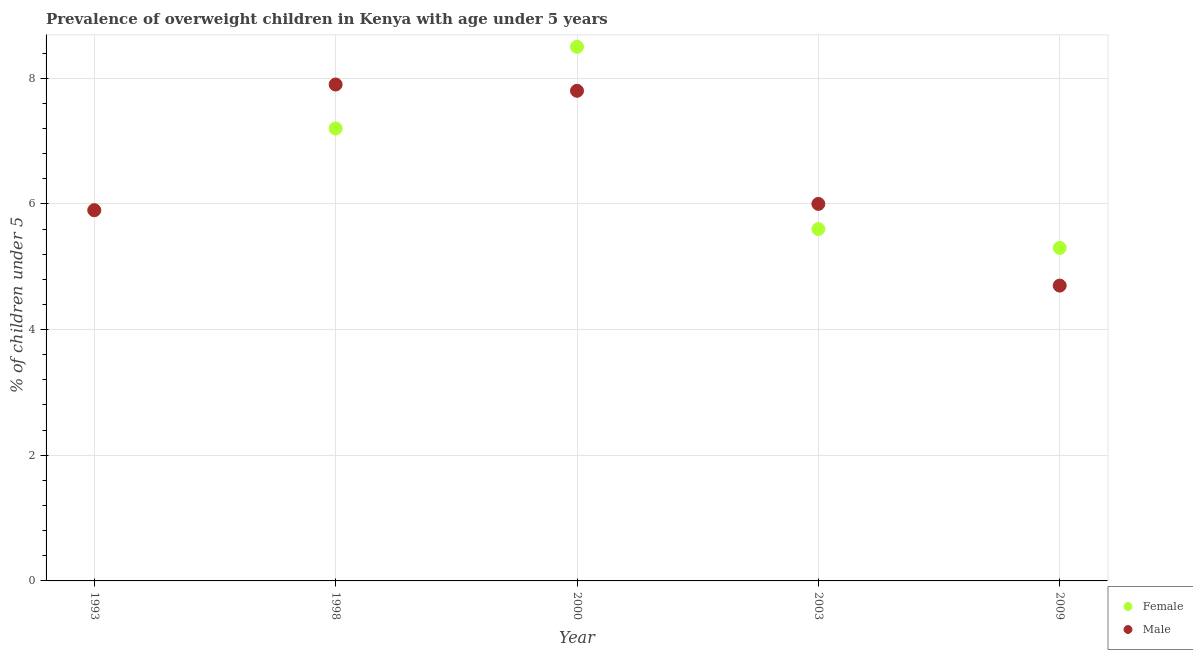What is the percentage of obese male children in 2003?
Your answer should be very brief. 6. Across all years, what is the maximum percentage of obese male children?
Provide a succinct answer. 7.9. Across all years, what is the minimum percentage of obese female children?
Your answer should be compact. 5.3. In which year was the percentage of obese female children minimum?
Offer a very short reply. 2009. What is the total percentage of obese male children in the graph?
Offer a very short reply. 32.3. What is the difference between the percentage of obese female children in 2003 and that in 2009?
Make the answer very short. 0.3. What is the difference between the percentage of obese male children in 1993 and the percentage of obese female children in 2009?
Keep it short and to the point. 0.6. What is the average percentage of obese male children per year?
Your answer should be compact. 6.46. In the year 2009, what is the difference between the percentage of obese male children and percentage of obese female children?
Provide a short and direct response. -0.6. In how many years, is the percentage of obese male children greater than 0.4 %?
Make the answer very short. 5. What is the ratio of the percentage of obese female children in 1993 to that in 1998?
Your response must be concise. 0.82. Is the difference between the percentage of obese female children in 2000 and 2003 greater than the difference between the percentage of obese male children in 2000 and 2003?
Provide a short and direct response. Yes. What is the difference between the highest and the second highest percentage of obese male children?
Offer a terse response. 0.1. What is the difference between the highest and the lowest percentage of obese male children?
Provide a succinct answer. 3.2. Is the percentage of obese male children strictly greater than the percentage of obese female children over the years?
Make the answer very short. No. Is the percentage of obese male children strictly less than the percentage of obese female children over the years?
Your answer should be very brief. No. How many years are there in the graph?
Offer a terse response. 5. Are the values on the major ticks of Y-axis written in scientific E-notation?
Keep it short and to the point. No. Where does the legend appear in the graph?
Your response must be concise. Bottom right. How are the legend labels stacked?
Offer a terse response. Vertical. What is the title of the graph?
Give a very brief answer. Prevalence of overweight children in Kenya with age under 5 years. Does "Study and work" appear as one of the legend labels in the graph?
Provide a short and direct response. No. What is the label or title of the X-axis?
Make the answer very short. Year. What is the label or title of the Y-axis?
Your response must be concise.  % of children under 5. What is the  % of children under 5 in Female in 1993?
Your response must be concise. 5.9. What is the  % of children under 5 of Male in 1993?
Offer a terse response. 5.9. What is the  % of children under 5 of Female in 1998?
Your answer should be very brief. 7.2. What is the  % of children under 5 in Male in 1998?
Provide a short and direct response. 7.9. What is the  % of children under 5 of Female in 2000?
Provide a short and direct response. 8.5. What is the  % of children under 5 of Male in 2000?
Give a very brief answer. 7.8. What is the  % of children under 5 of Female in 2003?
Your response must be concise. 5.6. What is the  % of children under 5 in Female in 2009?
Provide a short and direct response. 5.3. What is the  % of children under 5 of Male in 2009?
Provide a succinct answer. 4.7. Across all years, what is the maximum  % of children under 5 of Male?
Offer a very short reply. 7.9. Across all years, what is the minimum  % of children under 5 in Female?
Provide a short and direct response. 5.3. Across all years, what is the minimum  % of children under 5 in Male?
Your answer should be very brief. 4.7. What is the total  % of children under 5 of Female in the graph?
Offer a terse response. 32.5. What is the total  % of children under 5 in Male in the graph?
Your response must be concise. 32.3. What is the difference between the  % of children under 5 of Female in 1993 and that in 1998?
Your answer should be compact. -1.3. What is the difference between the  % of children under 5 in Female in 1993 and that in 2000?
Ensure brevity in your answer.  -2.6. What is the difference between the  % of children under 5 of Male in 1993 and that in 2000?
Provide a short and direct response. -1.9. What is the difference between the  % of children under 5 in Male in 1993 and that in 2003?
Offer a very short reply. -0.1. What is the difference between the  % of children under 5 of Female in 1993 and that in 2009?
Your answer should be very brief. 0.6. What is the difference between the  % of children under 5 in Male in 1993 and that in 2009?
Offer a terse response. 1.2. What is the difference between the  % of children under 5 of Female in 1998 and that in 2000?
Your answer should be very brief. -1.3. What is the difference between the  % of children under 5 in Male in 1998 and that in 2000?
Your response must be concise. 0.1. What is the difference between the  % of children under 5 in Female in 1998 and that in 2009?
Provide a short and direct response. 1.9. What is the difference between the  % of children under 5 in Female in 2000 and that in 2003?
Provide a succinct answer. 2.9. What is the difference between the  % of children under 5 of Male in 2000 and that in 2003?
Give a very brief answer. 1.8. What is the difference between the  % of children under 5 in Female in 2000 and that in 2009?
Ensure brevity in your answer.  3.2. What is the difference between the  % of children under 5 in Male in 2000 and that in 2009?
Give a very brief answer. 3.1. What is the difference between the  % of children under 5 in Male in 2003 and that in 2009?
Provide a succinct answer. 1.3. What is the difference between the  % of children under 5 in Female in 1993 and the  % of children under 5 in Male in 1998?
Provide a short and direct response. -2. What is the difference between the  % of children under 5 of Female in 1993 and the  % of children under 5 of Male in 2009?
Your answer should be compact. 1.2. What is the difference between the  % of children under 5 of Female in 1998 and the  % of children under 5 of Male in 2003?
Keep it short and to the point. 1.2. What is the difference between the  % of children under 5 in Female in 2000 and the  % of children under 5 in Male in 2009?
Offer a terse response. 3.8. What is the average  % of children under 5 in Female per year?
Make the answer very short. 6.5. What is the average  % of children under 5 of Male per year?
Offer a terse response. 6.46. In the year 2003, what is the difference between the  % of children under 5 of Female and  % of children under 5 of Male?
Offer a terse response. -0.4. What is the ratio of the  % of children under 5 in Female in 1993 to that in 1998?
Your answer should be very brief. 0.82. What is the ratio of the  % of children under 5 in Male in 1993 to that in 1998?
Provide a short and direct response. 0.75. What is the ratio of the  % of children under 5 in Female in 1993 to that in 2000?
Keep it short and to the point. 0.69. What is the ratio of the  % of children under 5 in Male in 1993 to that in 2000?
Your response must be concise. 0.76. What is the ratio of the  % of children under 5 in Female in 1993 to that in 2003?
Your answer should be very brief. 1.05. What is the ratio of the  % of children under 5 of Male in 1993 to that in 2003?
Provide a succinct answer. 0.98. What is the ratio of the  % of children under 5 of Female in 1993 to that in 2009?
Make the answer very short. 1.11. What is the ratio of the  % of children under 5 in Male in 1993 to that in 2009?
Your answer should be very brief. 1.26. What is the ratio of the  % of children under 5 in Female in 1998 to that in 2000?
Offer a very short reply. 0.85. What is the ratio of the  % of children under 5 in Male in 1998 to that in 2000?
Give a very brief answer. 1.01. What is the ratio of the  % of children under 5 in Female in 1998 to that in 2003?
Your answer should be very brief. 1.29. What is the ratio of the  % of children under 5 of Male in 1998 to that in 2003?
Ensure brevity in your answer.  1.32. What is the ratio of the  % of children under 5 of Female in 1998 to that in 2009?
Your answer should be compact. 1.36. What is the ratio of the  % of children under 5 in Male in 1998 to that in 2009?
Provide a succinct answer. 1.68. What is the ratio of the  % of children under 5 of Female in 2000 to that in 2003?
Ensure brevity in your answer.  1.52. What is the ratio of the  % of children under 5 of Female in 2000 to that in 2009?
Provide a short and direct response. 1.6. What is the ratio of the  % of children under 5 of Male in 2000 to that in 2009?
Ensure brevity in your answer.  1.66. What is the ratio of the  % of children under 5 in Female in 2003 to that in 2009?
Your answer should be very brief. 1.06. What is the ratio of the  % of children under 5 of Male in 2003 to that in 2009?
Provide a short and direct response. 1.28. 